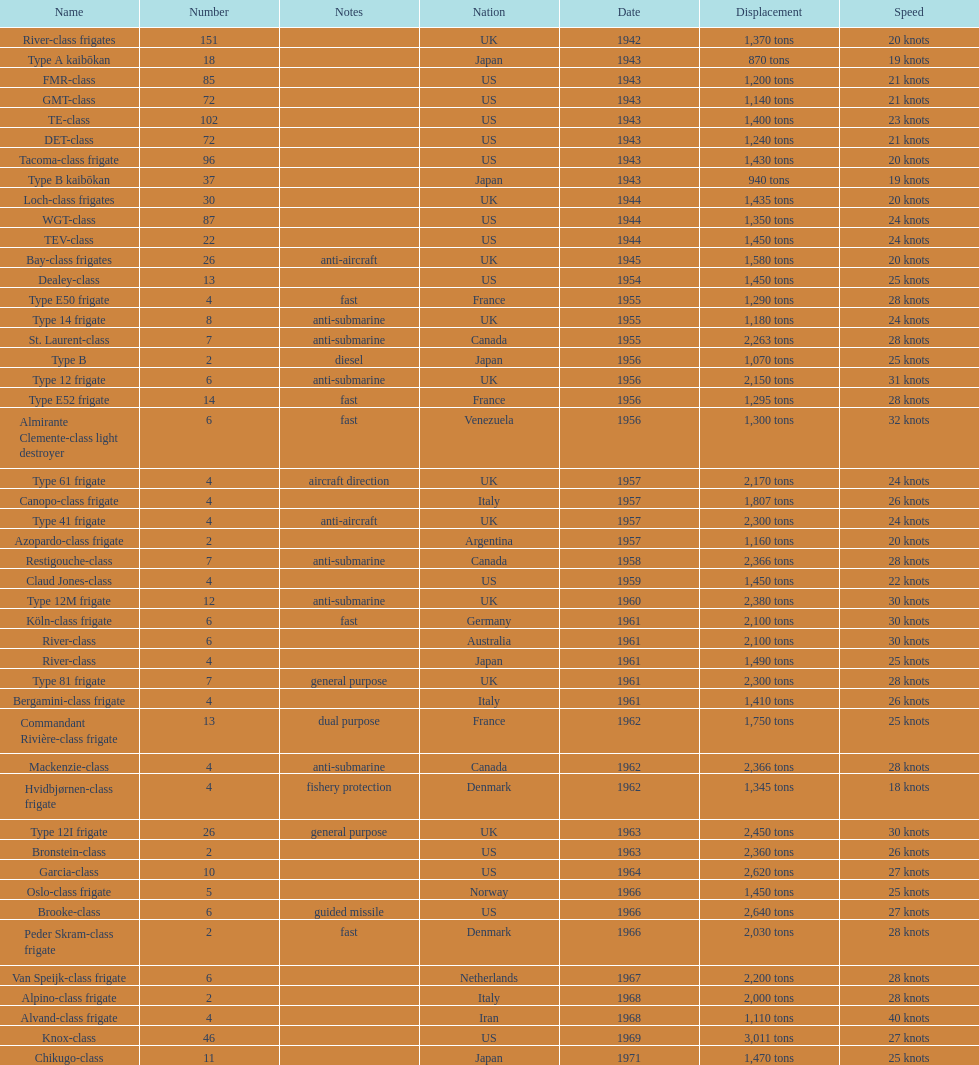How many tons does the te-class displace? 1,400 tons. 